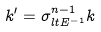Convert formula to latex. <formula><loc_0><loc_0><loc_500><loc_500>k ^ { \prime } = \sigma _ { l t E ^ { - 1 } } ^ { n - 1 } k</formula> 